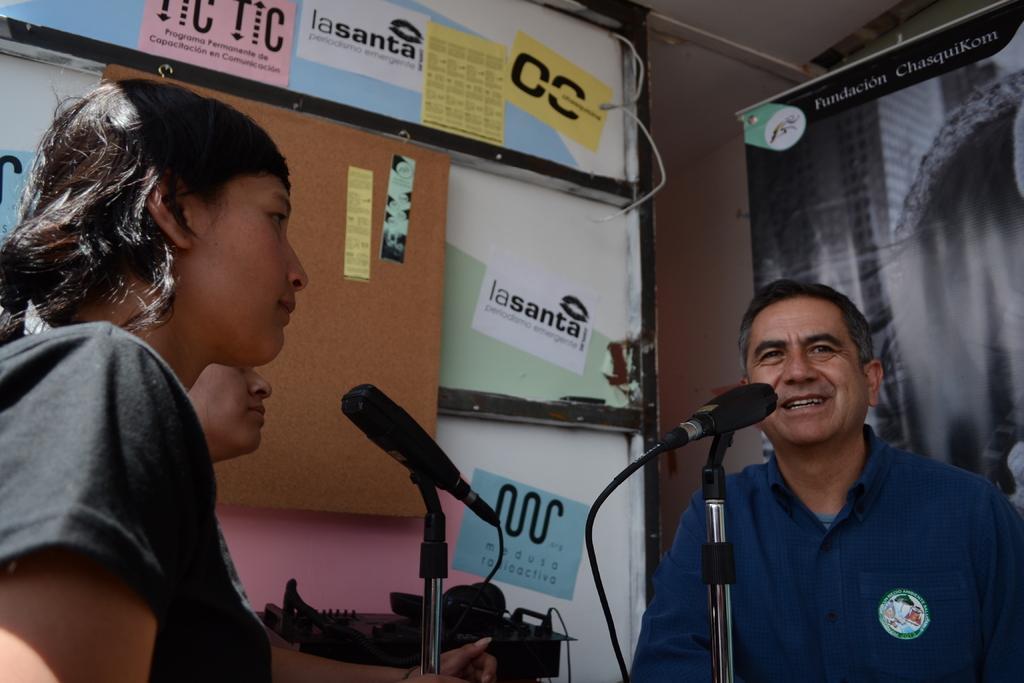In one or two sentences, can you explain what this image depicts? In this image there are a few people, in front of them there are a few mice and there is an object, in the background there are some posters are attached to the glass door. On the other side there is a banner with some text. 